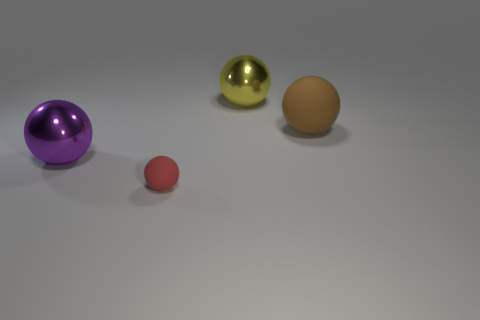Is there another red matte object of the same shape as the red rubber thing?
Provide a short and direct response. No. There is a rubber object on the right side of the large yellow metal ball left of the large brown object; what is its shape?
Make the answer very short. Sphere. What number of balls are either big brown matte objects or shiny objects?
Give a very brief answer. 3. Does the large shiny object that is behind the purple metal object have the same shape as the big rubber object right of the small object?
Make the answer very short. Yes. The big sphere that is to the left of the brown matte thing and in front of the yellow sphere is what color?
Offer a terse response. Purple. There is a small sphere; does it have the same color as the metal ball that is behind the big purple sphere?
Give a very brief answer. No. There is a sphere that is right of the red rubber sphere and in front of the yellow ball; what is its size?
Give a very brief answer. Large. How many other things are there of the same color as the big rubber object?
Keep it short and to the point. 0. There is a rubber thing on the right side of the metal object that is behind the big metallic sphere that is in front of the big brown matte sphere; what size is it?
Offer a very short reply. Large. There is a big matte object; are there any purple things behind it?
Provide a short and direct response. No. 